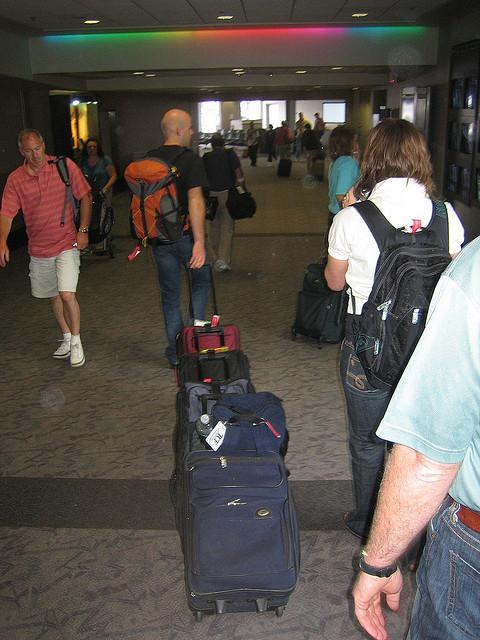Where are the people?
Keep it brief. Airport. Who has the most luggage?
Be succinct. Man. Is this an airport?
Short answer required. Yes. 